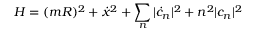<formula> <loc_0><loc_0><loc_500><loc_500>H = ( m R ) ^ { 2 } + { \dot { x } } ^ { 2 } + \sum _ { n } | { \dot { c } } _ { n } | ^ { 2 } + n ^ { 2 } | c _ { n } | ^ { 2 }</formula> 